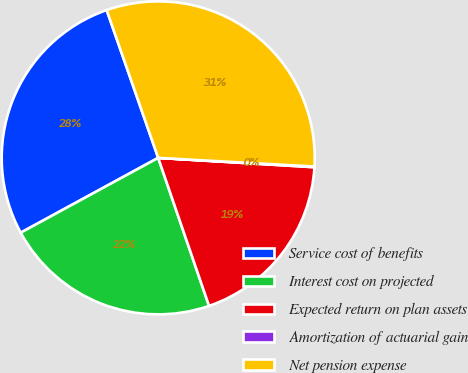<chart> <loc_0><loc_0><loc_500><loc_500><pie_chart><fcel>Service cost of benefits<fcel>Interest cost on projected<fcel>Expected return on plan assets<fcel>Amortization of actuarial gain<fcel>Net pension expense<nl><fcel>27.59%<fcel>22.33%<fcel>18.78%<fcel>0.07%<fcel>31.22%<nl></chart> 